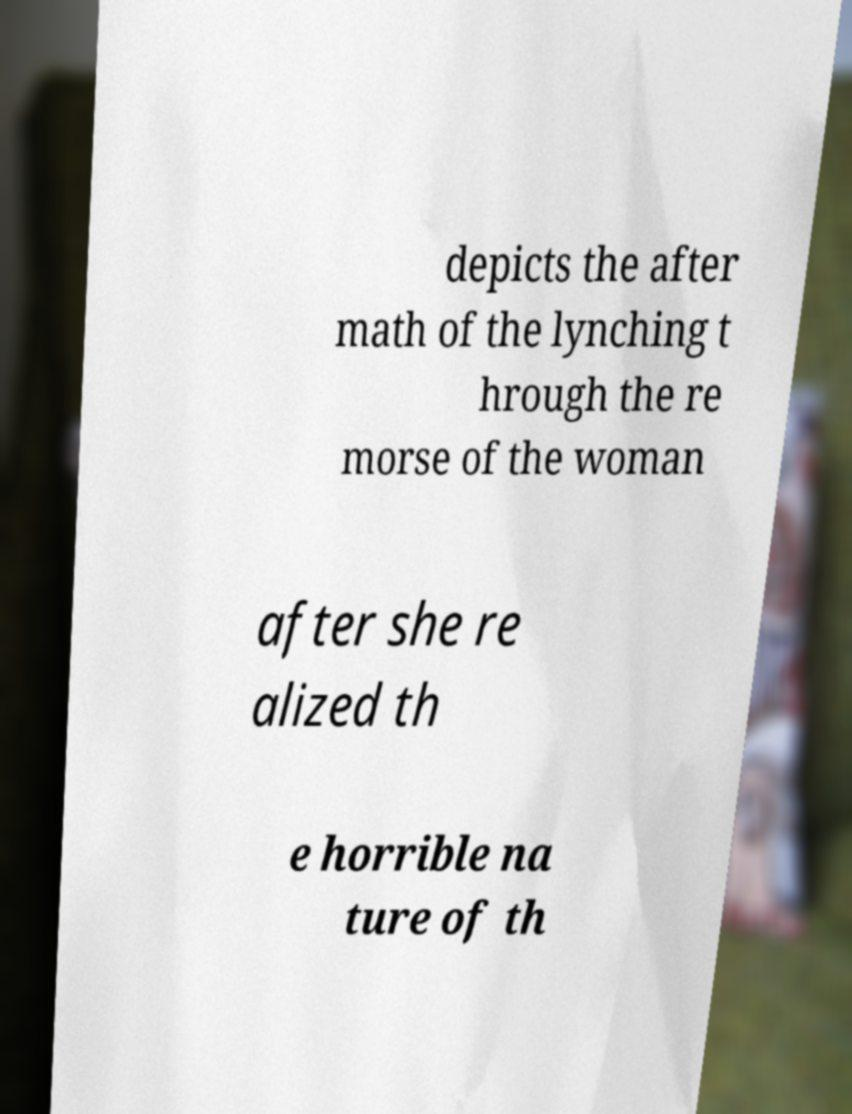Could you extract and type out the text from this image? depicts the after math of the lynching t hrough the re morse of the woman after she re alized th e horrible na ture of th 